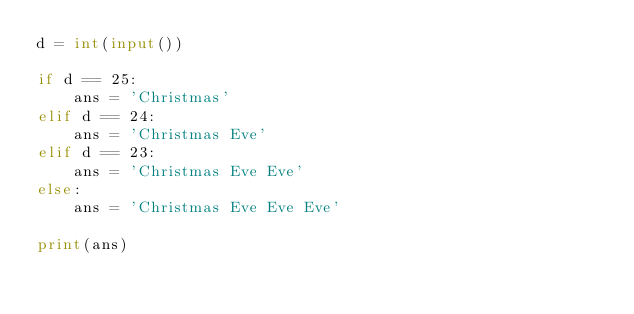Convert code to text. <code><loc_0><loc_0><loc_500><loc_500><_Python_>d = int(input())

if d == 25:
    ans = 'Christmas'
elif d == 24:
    ans = 'Christmas Eve'
elif d == 23:
    ans = 'Christmas Eve Eve'
else:
    ans = 'Christmas Eve Eve Eve'

print(ans)</code> 